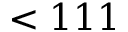<formula> <loc_0><loc_0><loc_500><loc_500>< 1 1 1</formula> 